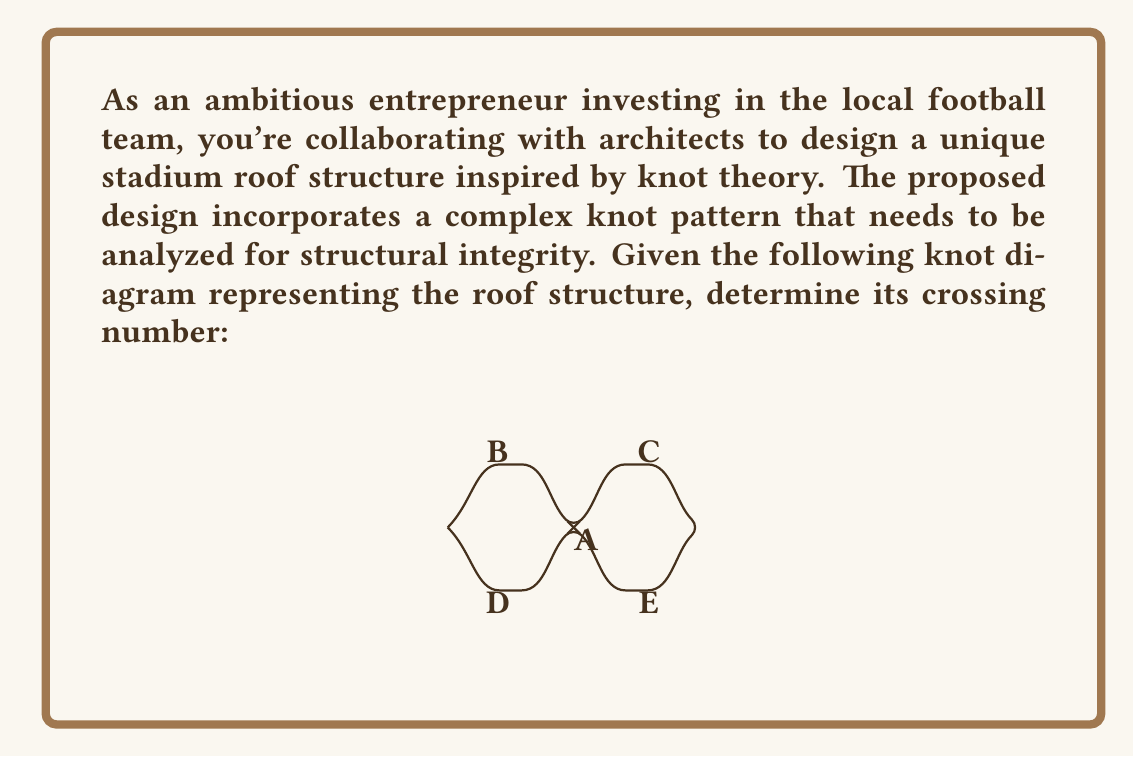Provide a solution to this math problem. To determine the crossing number of this complex knot pattern, we need to follow these steps:

1) First, let's understand what a crossing number is. In knot theory, the crossing number of a knot is the smallest number of crossings in any diagram of the knot.

2) In the given diagram, we can see that there are multiple crossings. Let's count them:
   - There's a clear crossing at point A in the center.
   - There are four other apparent crossings: at B, C, D, and E.

3) However, we need to be careful. In knot theory, we're looking for the minimum number of crossings. Sometimes, a knot diagram might show more crossings than necessary.

4) In this case, the diagram is actually showing an optimal representation. None of the crossings can be removed without fundamentally changing the knot.

5) The crossing at A is essential as it's the central point where multiple strands intersect.

6) The crossings at B, C, D, and E are also necessary. They create the loops that define the knot's structure.

7) Therefore, we count a total of 5 crossings: 1 at A, and 1 each at B, C, D, and E.

8) This count of 5 represents the minimum number of crossings needed to represent this knot, which is its crossing number.
Answer: 5 